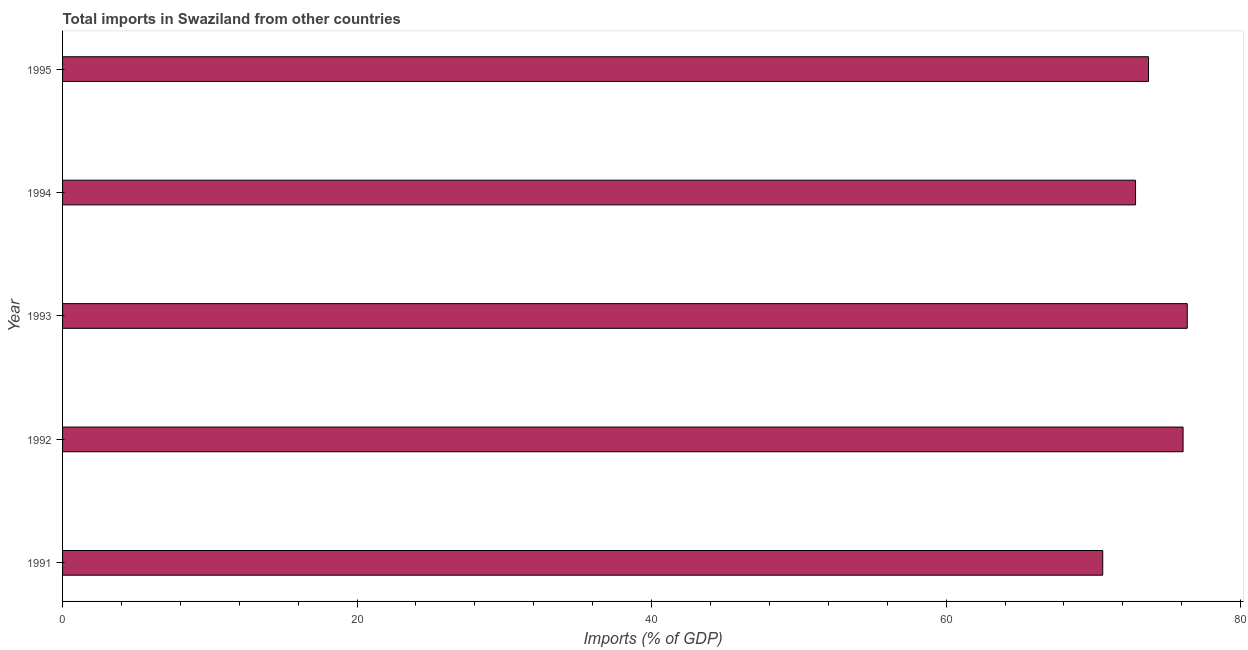Does the graph contain grids?
Make the answer very short. No. What is the title of the graph?
Offer a very short reply. Total imports in Swaziland from other countries. What is the label or title of the X-axis?
Your answer should be very brief. Imports (% of GDP). What is the total imports in 1995?
Offer a very short reply. 73.75. Across all years, what is the maximum total imports?
Your response must be concise. 76.38. Across all years, what is the minimum total imports?
Your answer should be very brief. 70.64. In which year was the total imports minimum?
Provide a succinct answer. 1991. What is the sum of the total imports?
Your response must be concise. 369.72. What is the difference between the total imports in 1991 and 1994?
Your answer should be compact. -2.23. What is the average total imports per year?
Provide a succinct answer. 73.94. What is the median total imports?
Ensure brevity in your answer.  73.75. Do a majority of the years between 1991 and 1995 (inclusive) have total imports greater than 52 %?
Offer a terse response. Yes. What is the ratio of the total imports in 1991 to that in 1995?
Provide a succinct answer. 0.96. Is the difference between the total imports in 1993 and 1994 greater than the difference between any two years?
Keep it short and to the point. No. What is the difference between the highest and the second highest total imports?
Your answer should be compact. 0.28. What is the difference between the highest and the lowest total imports?
Make the answer very short. 5.74. In how many years, is the total imports greater than the average total imports taken over all years?
Keep it short and to the point. 2. Are all the bars in the graph horizontal?
Your answer should be very brief. Yes. Are the values on the major ticks of X-axis written in scientific E-notation?
Keep it short and to the point. No. What is the Imports (% of GDP) of 1991?
Give a very brief answer. 70.64. What is the Imports (% of GDP) in 1992?
Ensure brevity in your answer.  76.09. What is the Imports (% of GDP) in 1993?
Offer a terse response. 76.38. What is the Imports (% of GDP) in 1994?
Your answer should be very brief. 72.87. What is the Imports (% of GDP) of 1995?
Offer a terse response. 73.75. What is the difference between the Imports (% of GDP) in 1991 and 1992?
Ensure brevity in your answer.  -5.46. What is the difference between the Imports (% of GDP) in 1991 and 1993?
Ensure brevity in your answer.  -5.74. What is the difference between the Imports (% of GDP) in 1991 and 1994?
Your answer should be compact. -2.23. What is the difference between the Imports (% of GDP) in 1991 and 1995?
Give a very brief answer. -3.11. What is the difference between the Imports (% of GDP) in 1992 and 1993?
Your response must be concise. -0.28. What is the difference between the Imports (% of GDP) in 1992 and 1994?
Offer a terse response. 3.23. What is the difference between the Imports (% of GDP) in 1992 and 1995?
Offer a very short reply. 2.35. What is the difference between the Imports (% of GDP) in 1993 and 1994?
Ensure brevity in your answer.  3.51. What is the difference between the Imports (% of GDP) in 1993 and 1995?
Make the answer very short. 2.63. What is the difference between the Imports (% of GDP) in 1994 and 1995?
Give a very brief answer. -0.88. What is the ratio of the Imports (% of GDP) in 1991 to that in 1992?
Your answer should be compact. 0.93. What is the ratio of the Imports (% of GDP) in 1991 to that in 1993?
Your answer should be compact. 0.93. What is the ratio of the Imports (% of GDP) in 1991 to that in 1995?
Your answer should be compact. 0.96. What is the ratio of the Imports (% of GDP) in 1992 to that in 1993?
Offer a very short reply. 1. What is the ratio of the Imports (% of GDP) in 1992 to that in 1994?
Offer a terse response. 1.04. What is the ratio of the Imports (% of GDP) in 1992 to that in 1995?
Your response must be concise. 1.03. What is the ratio of the Imports (% of GDP) in 1993 to that in 1994?
Provide a short and direct response. 1.05. What is the ratio of the Imports (% of GDP) in 1993 to that in 1995?
Keep it short and to the point. 1.04. 